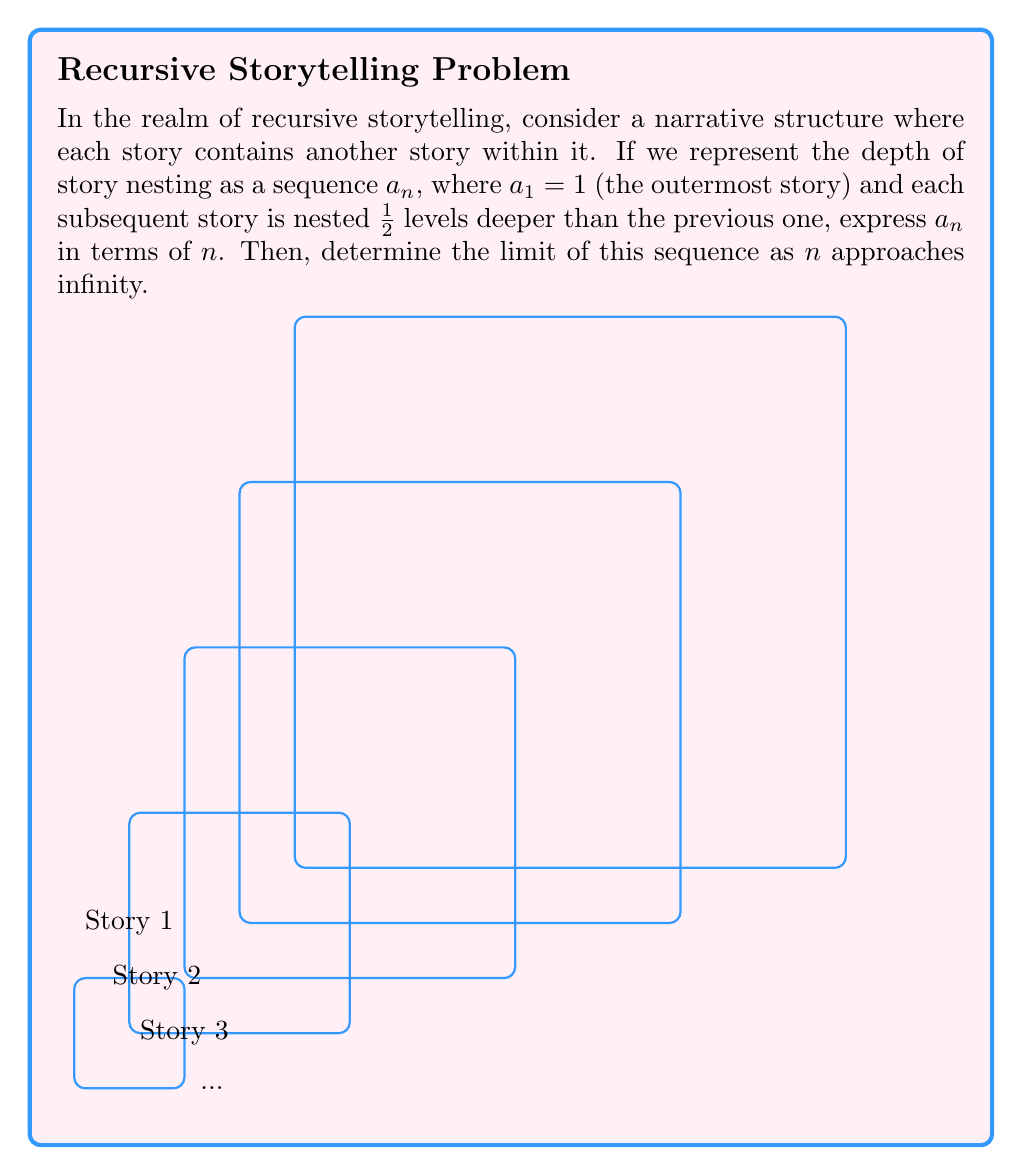Solve this math problem. Let's approach this step-by-step:

1) We're given that $a_1 = 1$ and each subsequent story is nested $\frac{1}{2}$ levels deeper than the previous one.

2) This means we can express the sequence as:
   $a_1 = 1$
   $a_2 = 1 + \frac{1}{2}$
   $a_3 = 1 + \frac{1}{2} + \frac{1}{2}$
   $a_4 = 1 + \frac{1}{2} + \frac{1}{2} + \frac{1}{2}$
   And so on...

3) We can see a pattern forming. For the $n$th term, we're adding $\frac{1}{2}$ a total of $(n-1)$ times to 1.

4) This can be expressed as:
   $a_n = 1 + (n-1) \cdot \frac{1}{2}$

5) Simplifying:
   $a_n = 1 + \frac{n-1}{2} = \frac{2 + n - 1}{2} = \frac{n + 1}{2}$

6) Now, to find the limit as $n$ approaches infinity:
   $$\lim_{n \to \infty} a_n = \lim_{n \to \infty} \frac{n + 1}{2}$$

7) As $n$ approaches infinity, the fraction $\frac{n + 1}{2}$ will grow without bound.

Therefore, the limit of this sequence as $n$ approaches infinity is infinity.
Answer: $a_n = \frac{n + 1}{2}$; $\lim_{n \to \infty} a_n = \infty$ 